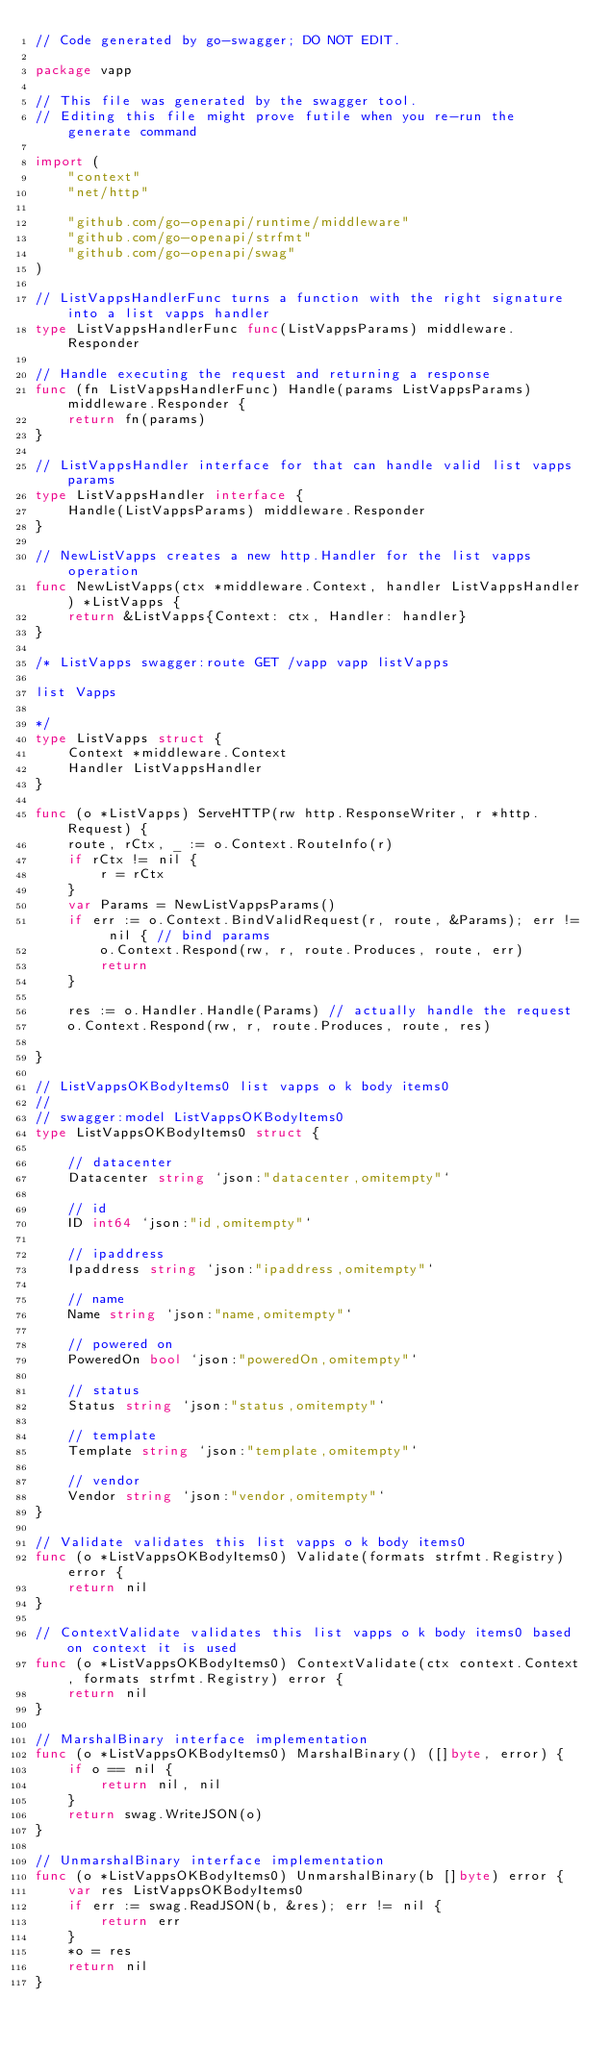Convert code to text. <code><loc_0><loc_0><loc_500><loc_500><_Go_>// Code generated by go-swagger; DO NOT EDIT.

package vapp

// This file was generated by the swagger tool.
// Editing this file might prove futile when you re-run the generate command

import (
	"context"
	"net/http"

	"github.com/go-openapi/runtime/middleware"
	"github.com/go-openapi/strfmt"
	"github.com/go-openapi/swag"
)

// ListVappsHandlerFunc turns a function with the right signature into a list vapps handler
type ListVappsHandlerFunc func(ListVappsParams) middleware.Responder

// Handle executing the request and returning a response
func (fn ListVappsHandlerFunc) Handle(params ListVappsParams) middleware.Responder {
	return fn(params)
}

// ListVappsHandler interface for that can handle valid list vapps params
type ListVappsHandler interface {
	Handle(ListVappsParams) middleware.Responder
}

// NewListVapps creates a new http.Handler for the list vapps operation
func NewListVapps(ctx *middleware.Context, handler ListVappsHandler) *ListVapps {
	return &ListVapps{Context: ctx, Handler: handler}
}

/* ListVapps swagger:route GET /vapp vapp listVapps

list Vapps

*/
type ListVapps struct {
	Context *middleware.Context
	Handler ListVappsHandler
}

func (o *ListVapps) ServeHTTP(rw http.ResponseWriter, r *http.Request) {
	route, rCtx, _ := o.Context.RouteInfo(r)
	if rCtx != nil {
		r = rCtx
	}
	var Params = NewListVappsParams()
	if err := o.Context.BindValidRequest(r, route, &Params); err != nil { // bind params
		o.Context.Respond(rw, r, route.Produces, route, err)
		return
	}

	res := o.Handler.Handle(Params) // actually handle the request
	o.Context.Respond(rw, r, route.Produces, route, res)

}

// ListVappsOKBodyItems0 list vapps o k body items0
//
// swagger:model ListVappsOKBodyItems0
type ListVappsOKBodyItems0 struct {

	// datacenter
	Datacenter string `json:"datacenter,omitempty"`

	// id
	ID int64 `json:"id,omitempty"`

	// ipaddress
	Ipaddress string `json:"ipaddress,omitempty"`

	// name
	Name string `json:"name,omitempty"`

	// powered on
	PoweredOn bool `json:"poweredOn,omitempty"`

	// status
	Status string `json:"status,omitempty"`

	// template
	Template string `json:"template,omitempty"`

	// vendor
	Vendor string `json:"vendor,omitempty"`
}

// Validate validates this list vapps o k body items0
func (o *ListVappsOKBodyItems0) Validate(formats strfmt.Registry) error {
	return nil
}

// ContextValidate validates this list vapps o k body items0 based on context it is used
func (o *ListVappsOKBodyItems0) ContextValidate(ctx context.Context, formats strfmt.Registry) error {
	return nil
}

// MarshalBinary interface implementation
func (o *ListVappsOKBodyItems0) MarshalBinary() ([]byte, error) {
	if o == nil {
		return nil, nil
	}
	return swag.WriteJSON(o)
}

// UnmarshalBinary interface implementation
func (o *ListVappsOKBodyItems0) UnmarshalBinary(b []byte) error {
	var res ListVappsOKBodyItems0
	if err := swag.ReadJSON(b, &res); err != nil {
		return err
	}
	*o = res
	return nil
}
</code> 